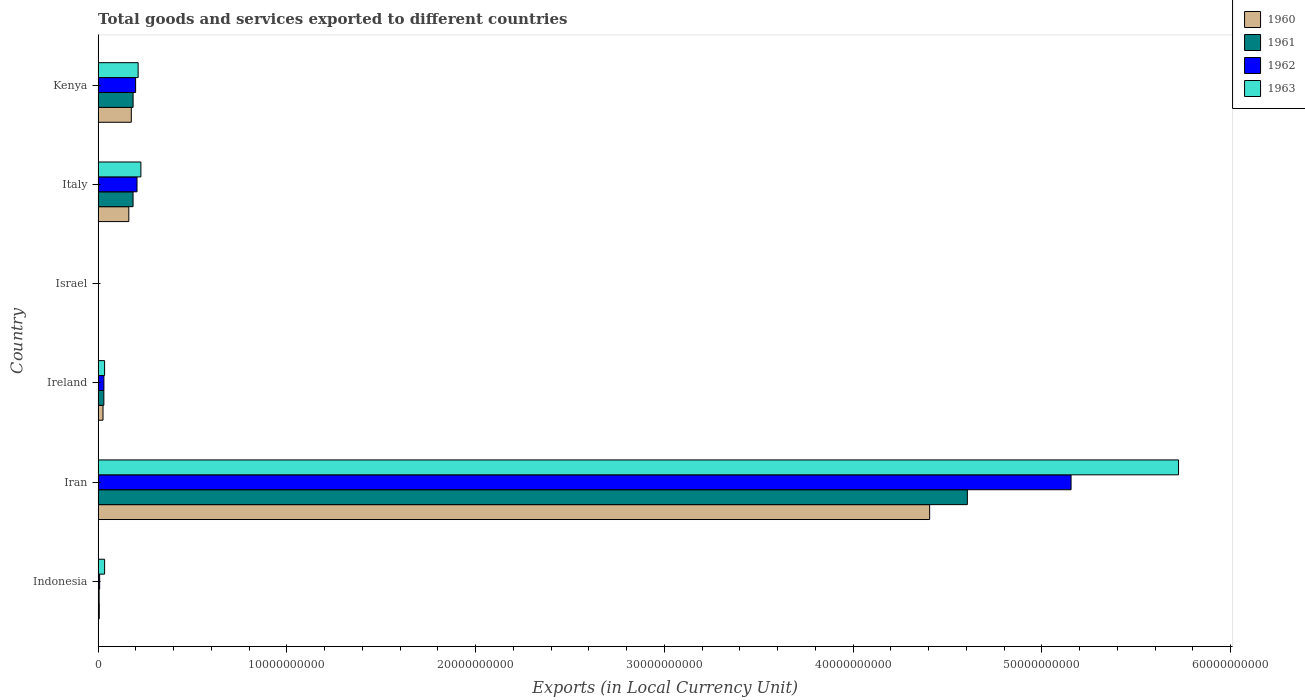How many different coloured bars are there?
Offer a terse response. 4. How many groups of bars are there?
Your answer should be very brief. 6. Are the number of bars on each tick of the Y-axis equal?
Your answer should be compact. Yes. How many bars are there on the 6th tick from the top?
Offer a very short reply. 4. What is the label of the 6th group of bars from the top?
Ensure brevity in your answer.  Indonesia. In how many cases, is the number of bars for a given country not equal to the number of legend labels?
Your answer should be compact. 0. What is the Amount of goods and services exports in 1962 in Kenya?
Provide a succinct answer. 1.99e+09. Across all countries, what is the maximum Amount of goods and services exports in 1962?
Offer a terse response. 5.15e+1. Across all countries, what is the minimum Amount of goods and services exports in 1962?
Keep it short and to the point. 1.34e+05. In which country was the Amount of goods and services exports in 1960 maximum?
Your answer should be compact. Iran. In which country was the Amount of goods and services exports in 1961 minimum?
Your answer should be compact. Israel. What is the total Amount of goods and services exports in 1961 in the graph?
Your answer should be very brief. 5.01e+1. What is the difference between the Amount of goods and services exports in 1960 in Israel and that in Kenya?
Offer a very short reply. -1.76e+09. What is the difference between the Amount of goods and services exports in 1961 in Ireland and the Amount of goods and services exports in 1960 in Indonesia?
Provide a succinct answer. 2.42e+08. What is the average Amount of goods and services exports in 1961 per country?
Provide a succinct answer. 8.35e+09. What is the difference between the Amount of goods and services exports in 1962 and Amount of goods and services exports in 1961 in Ireland?
Your answer should be very brief. 2.58e+06. What is the ratio of the Amount of goods and services exports in 1961 in Indonesia to that in Iran?
Give a very brief answer. 0. What is the difference between the highest and the second highest Amount of goods and services exports in 1960?
Your answer should be compact. 4.23e+1. What is the difference between the highest and the lowest Amount of goods and services exports in 1962?
Your response must be concise. 5.15e+1. In how many countries, is the Amount of goods and services exports in 1961 greater than the average Amount of goods and services exports in 1961 taken over all countries?
Keep it short and to the point. 1. What does the 1st bar from the bottom in Israel represents?
Your response must be concise. 1960. Is it the case that in every country, the sum of the Amount of goods and services exports in 1962 and Amount of goods and services exports in 1963 is greater than the Amount of goods and services exports in 1960?
Ensure brevity in your answer.  Yes. How many bars are there?
Give a very brief answer. 24. Are all the bars in the graph horizontal?
Offer a very short reply. Yes. What is the difference between two consecutive major ticks on the X-axis?
Give a very brief answer. 1.00e+1. Are the values on the major ticks of X-axis written in scientific E-notation?
Ensure brevity in your answer.  No. Does the graph contain grids?
Your answer should be very brief. No. How many legend labels are there?
Offer a very short reply. 4. How are the legend labels stacked?
Keep it short and to the point. Vertical. What is the title of the graph?
Ensure brevity in your answer.  Total goods and services exported to different countries. What is the label or title of the X-axis?
Make the answer very short. Exports (in Local Currency Unit). What is the label or title of the Y-axis?
Offer a very short reply. Country. What is the Exports (in Local Currency Unit) of 1960 in Indonesia?
Provide a short and direct response. 6.20e+07. What is the Exports (in Local Currency Unit) in 1961 in Indonesia?
Offer a very short reply. 5.31e+07. What is the Exports (in Local Currency Unit) in 1962 in Indonesia?
Your response must be concise. 8.19e+07. What is the Exports (in Local Currency Unit) of 1963 in Indonesia?
Offer a very short reply. 3.44e+08. What is the Exports (in Local Currency Unit) of 1960 in Iran?
Make the answer very short. 4.41e+1. What is the Exports (in Local Currency Unit) of 1961 in Iran?
Provide a short and direct response. 4.60e+1. What is the Exports (in Local Currency Unit) in 1962 in Iran?
Ensure brevity in your answer.  5.15e+1. What is the Exports (in Local Currency Unit) in 1963 in Iran?
Make the answer very short. 5.72e+1. What is the Exports (in Local Currency Unit) in 1960 in Ireland?
Provide a succinct answer. 2.60e+08. What is the Exports (in Local Currency Unit) of 1961 in Ireland?
Offer a terse response. 3.04e+08. What is the Exports (in Local Currency Unit) of 1962 in Ireland?
Make the answer very short. 3.07e+08. What is the Exports (in Local Currency Unit) of 1963 in Ireland?
Your answer should be compact. 3.43e+08. What is the Exports (in Local Currency Unit) of 1960 in Israel?
Your response must be concise. 6.19e+04. What is the Exports (in Local Currency Unit) in 1961 in Israel?
Your answer should be very brief. 7.24e+04. What is the Exports (in Local Currency Unit) of 1962 in Israel?
Your answer should be compact. 1.34e+05. What is the Exports (in Local Currency Unit) in 1963 in Israel?
Make the answer very short. 1.67e+05. What is the Exports (in Local Currency Unit) in 1960 in Italy?
Provide a short and direct response. 1.63e+09. What is the Exports (in Local Currency Unit) of 1961 in Italy?
Offer a terse response. 1.85e+09. What is the Exports (in Local Currency Unit) in 1962 in Italy?
Your response must be concise. 2.06e+09. What is the Exports (in Local Currency Unit) in 1963 in Italy?
Offer a very short reply. 2.27e+09. What is the Exports (in Local Currency Unit) in 1960 in Kenya?
Provide a short and direct response. 1.76e+09. What is the Exports (in Local Currency Unit) of 1961 in Kenya?
Provide a short and direct response. 1.85e+09. What is the Exports (in Local Currency Unit) in 1962 in Kenya?
Your answer should be compact. 1.99e+09. What is the Exports (in Local Currency Unit) of 1963 in Kenya?
Offer a terse response. 2.12e+09. Across all countries, what is the maximum Exports (in Local Currency Unit) of 1960?
Offer a terse response. 4.41e+1. Across all countries, what is the maximum Exports (in Local Currency Unit) of 1961?
Offer a terse response. 4.60e+1. Across all countries, what is the maximum Exports (in Local Currency Unit) in 1962?
Your response must be concise. 5.15e+1. Across all countries, what is the maximum Exports (in Local Currency Unit) of 1963?
Provide a short and direct response. 5.72e+1. Across all countries, what is the minimum Exports (in Local Currency Unit) in 1960?
Provide a succinct answer. 6.19e+04. Across all countries, what is the minimum Exports (in Local Currency Unit) of 1961?
Your answer should be compact. 7.24e+04. Across all countries, what is the minimum Exports (in Local Currency Unit) in 1962?
Keep it short and to the point. 1.34e+05. Across all countries, what is the minimum Exports (in Local Currency Unit) of 1963?
Your answer should be very brief. 1.67e+05. What is the total Exports (in Local Currency Unit) of 1960 in the graph?
Ensure brevity in your answer.  4.78e+1. What is the total Exports (in Local Currency Unit) in 1961 in the graph?
Give a very brief answer. 5.01e+1. What is the total Exports (in Local Currency Unit) in 1962 in the graph?
Give a very brief answer. 5.60e+1. What is the total Exports (in Local Currency Unit) of 1963 in the graph?
Give a very brief answer. 6.23e+1. What is the difference between the Exports (in Local Currency Unit) in 1960 in Indonesia and that in Iran?
Provide a short and direct response. -4.40e+1. What is the difference between the Exports (in Local Currency Unit) of 1961 in Indonesia and that in Iran?
Provide a succinct answer. -4.60e+1. What is the difference between the Exports (in Local Currency Unit) in 1962 in Indonesia and that in Iran?
Offer a very short reply. -5.15e+1. What is the difference between the Exports (in Local Currency Unit) of 1963 in Indonesia and that in Iran?
Offer a very short reply. -5.69e+1. What is the difference between the Exports (in Local Currency Unit) in 1960 in Indonesia and that in Ireland?
Ensure brevity in your answer.  -1.98e+08. What is the difference between the Exports (in Local Currency Unit) in 1961 in Indonesia and that in Ireland?
Offer a very short reply. -2.51e+08. What is the difference between the Exports (in Local Currency Unit) in 1962 in Indonesia and that in Ireland?
Your answer should be compact. -2.25e+08. What is the difference between the Exports (in Local Currency Unit) in 1963 in Indonesia and that in Ireland?
Provide a short and direct response. 1.22e+06. What is the difference between the Exports (in Local Currency Unit) in 1960 in Indonesia and that in Israel?
Your response must be concise. 6.19e+07. What is the difference between the Exports (in Local Currency Unit) in 1961 in Indonesia and that in Israel?
Provide a short and direct response. 5.31e+07. What is the difference between the Exports (in Local Currency Unit) in 1962 in Indonesia and that in Israel?
Provide a succinct answer. 8.18e+07. What is the difference between the Exports (in Local Currency Unit) in 1963 in Indonesia and that in Israel?
Your answer should be very brief. 3.44e+08. What is the difference between the Exports (in Local Currency Unit) in 1960 in Indonesia and that in Italy?
Your response must be concise. -1.56e+09. What is the difference between the Exports (in Local Currency Unit) of 1961 in Indonesia and that in Italy?
Provide a short and direct response. -1.80e+09. What is the difference between the Exports (in Local Currency Unit) in 1962 in Indonesia and that in Italy?
Your answer should be very brief. -1.98e+09. What is the difference between the Exports (in Local Currency Unit) of 1963 in Indonesia and that in Italy?
Give a very brief answer. -1.92e+09. What is the difference between the Exports (in Local Currency Unit) of 1960 in Indonesia and that in Kenya?
Your response must be concise. -1.70e+09. What is the difference between the Exports (in Local Currency Unit) in 1961 in Indonesia and that in Kenya?
Offer a very short reply. -1.80e+09. What is the difference between the Exports (in Local Currency Unit) in 1962 in Indonesia and that in Kenya?
Give a very brief answer. -1.90e+09. What is the difference between the Exports (in Local Currency Unit) in 1963 in Indonesia and that in Kenya?
Keep it short and to the point. -1.78e+09. What is the difference between the Exports (in Local Currency Unit) in 1960 in Iran and that in Ireland?
Give a very brief answer. 4.38e+1. What is the difference between the Exports (in Local Currency Unit) in 1961 in Iran and that in Ireland?
Make the answer very short. 4.57e+1. What is the difference between the Exports (in Local Currency Unit) of 1962 in Iran and that in Ireland?
Make the answer very short. 5.12e+1. What is the difference between the Exports (in Local Currency Unit) in 1963 in Iran and that in Ireland?
Your response must be concise. 5.69e+1. What is the difference between the Exports (in Local Currency Unit) of 1960 in Iran and that in Israel?
Offer a very short reply. 4.41e+1. What is the difference between the Exports (in Local Currency Unit) of 1961 in Iran and that in Israel?
Keep it short and to the point. 4.60e+1. What is the difference between the Exports (in Local Currency Unit) of 1962 in Iran and that in Israel?
Your answer should be very brief. 5.15e+1. What is the difference between the Exports (in Local Currency Unit) in 1963 in Iran and that in Israel?
Make the answer very short. 5.72e+1. What is the difference between the Exports (in Local Currency Unit) of 1960 in Iran and that in Italy?
Keep it short and to the point. 4.24e+1. What is the difference between the Exports (in Local Currency Unit) of 1961 in Iran and that in Italy?
Offer a very short reply. 4.42e+1. What is the difference between the Exports (in Local Currency Unit) of 1962 in Iran and that in Italy?
Your answer should be compact. 4.95e+1. What is the difference between the Exports (in Local Currency Unit) in 1963 in Iran and that in Italy?
Make the answer very short. 5.50e+1. What is the difference between the Exports (in Local Currency Unit) of 1960 in Iran and that in Kenya?
Your answer should be very brief. 4.23e+1. What is the difference between the Exports (in Local Currency Unit) in 1961 in Iran and that in Kenya?
Give a very brief answer. 4.42e+1. What is the difference between the Exports (in Local Currency Unit) in 1962 in Iran and that in Kenya?
Ensure brevity in your answer.  4.96e+1. What is the difference between the Exports (in Local Currency Unit) of 1963 in Iran and that in Kenya?
Offer a terse response. 5.51e+1. What is the difference between the Exports (in Local Currency Unit) of 1960 in Ireland and that in Israel?
Provide a short and direct response. 2.60e+08. What is the difference between the Exports (in Local Currency Unit) in 1961 in Ireland and that in Israel?
Offer a very short reply. 3.04e+08. What is the difference between the Exports (in Local Currency Unit) of 1962 in Ireland and that in Israel?
Give a very brief answer. 3.06e+08. What is the difference between the Exports (in Local Currency Unit) of 1963 in Ireland and that in Israel?
Your response must be concise. 3.43e+08. What is the difference between the Exports (in Local Currency Unit) in 1960 in Ireland and that in Italy?
Offer a terse response. -1.37e+09. What is the difference between the Exports (in Local Currency Unit) in 1961 in Ireland and that in Italy?
Your answer should be compact. -1.55e+09. What is the difference between the Exports (in Local Currency Unit) in 1962 in Ireland and that in Italy?
Give a very brief answer. -1.75e+09. What is the difference between the Exports (in Local Currency Unit) in 1963 in Ireland and that in Italy?
Make the answer very short. -1.92e+09. What is the difference between the Exports (in Local Currency Unit) of 1960 in Ireland and that in Kenya?
Offer a terse response. -1.50e+09. What is the difference between the Exports (in Local Currency Unit) in 1961 in Ireland and that in Kenya?
Your response must be concise. -1.55e+09. What is the difference between the Exports (in Local Currency Unit) of 1962 in Ireland and that in Kenya?
Keep it short and to the point. -1.68e+09. What is the difference between the Exports (in Local Currency Unit) of 1963 in Ireland and that in Kenya?
Offer a very short reply. -1.78e+09. What is the difference between the Exports (in Local Currency Unit) in 1960 in Israel and that in Italy?
Keep it short and to the point. -1.63e+09. What is the difference between the Exports (in Local Currency Unit) in 1961 in Israel and that in Italy?
Provide a short and direct response. -1.85e+09. What is the difference between the Exports (in Local Currency Unit) of 1962 in Israel and that in Italy?
Provide a succinct answer. -2.06e+09. What is the difference between the Exports (in Local Currency Unit) in 1963 in Israel and that in Italy?
Make the answer very short. -2.27e+09. What is the difference between the Exports (in Local Currency Unit) of 1960 in Israel and that in Kenya?
Offer a very short reply. -1.76e+09. What is the difference between the Exports (in Local Currency Unit) of 1961 in Israel and that in Kenya?
Provide a short and direct response. -1.85e+09. What is the difference between the Exports (in Local Currency Unit) in 1962 in Israel and that in Kenya?
Your answer should be compact. -1.99e+09. What is the difference between the Exports (in Local Currency Unit) of 1963 in Israel and that in Kenya?
Provide a short and direct response. -2.12e+09. What is the difference between the Exports (in Local Currency Unit) of 1960 in Italy and that in Kenya?
Ensure brevity in your answer.  -1.31e+08. What is the difference between the Exports (in Local Currency Unit) in 1961 in Italy and that in Kenya?
Keep it short and to the point. -1.45e+06. What is the difference between the Exports (in Local Currency Unit) in 1962 in Italy and that in Kenya?
Provide a succinct answer. 7.40e+07. What is the difference between the Exports (in Local Currency Unit) in 1963 in Italy and that in Kenya?
Your answer should be compact. 1.46e+08. What is the difference between the Exports (in Local Currency Unit) of 1960 in Indonesia and the Exports (in Local Currency Unit) of 1961 in Iran?
Your answer should be compact. -4.60e+1. What is the difference between the Exports (in Local Currency Unit) of 1960 in Indonesia and the Exports (in Local Currency Unit) of 1962 in Iran?
Ensure brevity in your answer.  -5.15e+1. What is the difference between the Exports (in Local Currency Unit) in 1960 in Indonesia and the Exports (in Local Currency Unit) in 1963 in Iran?
Make the answer very short. -5.72e+1. What is the difference between the Exports (in Local Currency Unit) of 1961 in Indonesia and the Exports (in Local Currency Unit) of 1962 in Iran?
Ensure brevity in your answer.  -5.15e+1. What is the difference between the Exports (in Local Currency Unit) in 1961 in Indonesia and the Exports (in Local Currency Unit) in 1963 in Iran?
Keep it short and to the point. -5.72e+1. What is the difference between the Exports (in Local Currency Unit) of 1962 in Indonesia and the Exports (in Local Currency Unit) of 1963 in Iran?
Keep it short and to the point. -5.72e+1. What is the difference between the Exports (in Local Currency Unit) in 1960 in Indonesia and the Exports (in Local Currency Unit) in 1961 in Ireland?
Your answer should be compact. -2.42e+08. What is the difference between the Exports (in Local Currency Unit) in 1960 in Indonesia and the Exports (in Local Currency Unit) in 1962 in Ireland?
Give a very brief answer. -2.45e+08. What is the difference between the Exports (in Local Currency Unit) of 1960 in Indonesia and the Exports (in Local Currency Unit) of 1963 in Ireland?
Your answer should be compact. -2.81e+08. What is the difference between the Exports (in Local Currency Unit) of 1961 in Indonesia and the Exports (in Local Currency Unit) of 1962 in Ireland?
Provide a short and direct response. -2.53e+08. What is the difference between the Exports (in Local Currency Unit) in 1961 in Indonesia and the Exports (in Local Currency Unit) in 1963 in Ireland?
Offer a terse response. -2.90e+08. What is the difference between the Exports (in Local Currency Unit) in 1962 in Indonesia and the Exports (in Local Currency Unit) in 1963 in Ireland?
Keep it short and to the point. -2.61e+08. What is the difference between the Exports (in Local Currency Unit) of 1960 in Indonesia and the Exports (in Local Currency Unit) of 1961 in Israel?
Your answer should be compact. 6.19e+07. What is the difference between the Exports (in Local Currency Unit) of 1960 in Indonesia and the Exports (in Local Currency Unit) of 1962 in Israel?
Your response must be concise. 6.18e+07. What is the difference between the Exports (in Local Currency Unit) of 1960 in Indonesia and the Exports (in Local Currency Unit) of 1963 in Israel?
Ensure brevity in your answer.  6.18e+07. What is the difference between the Exports (in Local Currency Unit) of 1961 in Indonesia and the Exports (in Local Currency Unit) of 1962 in Israel?
Keep it short and to the point. 5.30e+07. What is the difference between the Exports (in Local Currency Unit) in 1961 in Indonesia and the Exports (in Local Currency Unit) in 1963 in Israel?
Give a very brief answer. 5.30e+07. What is the difference between the Exports (in Local Currency Unit) in 1962 in Indonesia and the Exports (in Local Currency Unit) in 1963 in Israel?
Make the answer very short. 8.17e+07. What is the difference between the Exports (in Local Currency Unit) of 1960 in Indonesia and the Exports (in Local Currency Unit) of 1961 in Italy?
Your response must be concise. -1.79e+09. What is the difference between the Exports (in Local Currency Unit) of 1960 in Indonesia and the Exports (in Local Currency Unit) of 1962 in Italy?
Your answer should be very brief. -2.00e+09. What is the difference between the Exports (in Local Currency Unit) in 1960 in Indonesia and the Exports (in Local Currency Unit) in 1963 in Italy?
Your answer should be very brief. -2.20e+09. What is the difference between the Exports (in Local Currency Unit) of 1961 in Indonesia and the Exports (in Local Currency Unit) of 1962 in Italy?
Provide a succinct answer. -2.01e+09. What is the difference between the Exports (in Local Currency Unit) of 1961 in Indonesia and the Exports (in Local Currency Unit) of 1963 in Italy?
Your answer should be compact. -2.21e+09. What is the difference between the Exports (in Local Currency Unit) of 1962 in Indonesia and the Exports (in Local Currency Unit) of 1963 in Italy?
Keep it short and to the point. -2.18e+09. What is the difference between the Exports (in Local Currency Unit) in 1960 in Indonesia and the Exports (in Local Currency Unit) in 1961 in Kenya?
Provide a succinct answer. -1.79e+09. What is the difference between the Exports (in Local Currency Unit) in 1960 in Indonesia and the Exports (in Local Currency Unit) in 1962 in Kenya?
Your response must be concise. -1.92e+09. What is the difference between the Exports (in Local Currency Unit) of 1960 in Indonesia and the Exports (in Local Currency Unit) of 1963 in Kenya?
Your response must be concise. -2.06e+09. What is the difference between the Exports (in Local Currency Unit) in 1961 in Indonesia and the Exports (in Local Currency Unit) in 1962 in Kenya?
Your answer should be very brief. -1.93e+09. What is the difference between the Exports (in Local Currency Unit) in 1961 in Indonesia and the Exports (in Local Currency Unit) in 1963 in Kenya?
Provide a succinct answer. -2.07e+09. What is the difference between the Exports (in Local Currency Unit) in 1962 in Indonesia and the Exports (in Local Currency Unit) in 1963 in Kenya?
Provide a short and direct response. -2.04e+09. What is the difference between the Exports (in Local Currency Unit) of 1960 in Iran and the Exports (in Local Currency Unit) of 1961 in Ireland?
Offer a terse response. 4.37e+1. What is the difference between the Exports (in Local Currency Unit) of 1960 in Iran and the Exports (in Local Currency Unit) of 1962 in Ireland?
Provide a short and direct response. 4.37e+1. What is the difference between the Exports (in Local Currency Unit) in 1960 in Iran and the Exports (in Local Currency Unit) in 1963 in Ireland?
Offer a very short reply. 4.37e+1. What is the difference between the Exports (in Local Currency Unit) of 1961 in Iran and the Exports (in Local Currency Unit) of 1962 in Ireland?
Ensure brevity in your answer.  4.57e+1. What is the difference between the Exports (in Local Currency Unit) of 1961 in Iran and the Exports (in Local Currency Unit) of 1963 in Ireland?
Offer a very short reply. 4.57e+1. What is the difference between the Exports (in Local Currency Unit) in 1962 in Iran and the Exports (in Local Currency Unit) in 1963 in Ireland?
Ensure brevity in your answer.  5.12e+1. What is the difference between the Exports (in Local Currency Unit) of 1960 in Iran and the Exports (in Local Currency Unit) of 1961 in Israel?
Ensure brevity in your answer.  4.41e+1. What is the difference between the Exports (in Local Currency Unit) in 1960 in Iran and the Exports (in Local Currency Unit) in 1962 in Israel?
Your answer should be very brief. 4.41e+1. What is the difference between the Exports (in Local Currency Unit) of 1960 in Iran and the Exports (in Local Currency Unit) of 1963 in Israel?
Offer a very short reply. 4.41e+1. What is the difference between the Exports (in Local Currency Unit) of 1961 in Iran and the Exports (in Local Currency Unit) of 1962 in Israel?
Provide a short and direct response. 4.60e+1. What is the difference between the Exports (in Local Currency Unit) of 1961 in Iran and the Exports (in Local Currency Unit) of 1963 in Israel?
Your answer should be very brief. 4.60e+1. What is the difference between the Exports (in Local Currency Unit) in 1962 in Iran and the Exports (in Local Currency Unit) in 1963 in Israel?
Provide a short and direct response. 5.15e+1. What is the difference between the Exports (in Local Currency Unit) of 1960 in Iran and the Exports (in Local Currency Unit) of 1961 in Italy?
Give a very brief answer. 4.22e+1. What is the difference between the Exports (in Local Currency Unit) in 1960 in Iran and the Exports (in Local Currency Unit) in 1962 in Italy?
Keep it short and to the point. 4.20e+1. What is the difference between the Exports (in Local Currency Unit) in 1960 in Iran and the Exports (in Local Currency Unit) in 1963 in Italy?
Offer a terse response. 4.18e+1. What is the difference between the Exports (in Local Currency Unit) in 1961 in Iran and the Exports (in Local Currency Unit) in 1962 in Italy?
Your response must be concise. 4.40e+1. What is the difference between the Exports (in Local Currency Unit) of 1961 in Iran and the Exports (in Local Currency Unit) of 1963 in Italy?
Provide a short and direct response. 4.38e+1. What is the difference between the Exports (in Local Currency Unit) in 1962 in Iran and the Exports (in Local Currency Unit) in 1963 in Italy?
Your answer should be very brief. 4.93e+1. What is the difference between the Exports (in Local Currency Unit) of 1960 in Iran and the Exports (in Local Currency Unit) of 1961 in Kenya?
Give a very brief answer. 4.22e+1. What is the difference between the Exports (in Local Currency Unit) of 1960 in Iran and the Exports (in Local Currency Unit) of 1962 in Kenya?
Offer a terse response. 4.21e+1. What is the difference between the Exports (in Local Currency Unit) of 1960 in Iran and the Exports (in Local Currency Unit) of 1963 in Kenya?
Ensure brevity in your answer.  4.19e+1. What is the difference between the Exports (in Local Currency Unit) in 1961 in Iran and the Exports (in Local Currency Unit) in 1962 in Kenya?
Keep it short and to the point. 4.41e+1. What is the difference between the Exports (in Local Currency Unit) of 1961 in Iran and the Exports (in Local Currency Unit) of 1963 in Kenya?
Provide a short and direct response. 4.39e+1. What is the difference between the Exports (in Local Currency Unit) of 1962 in Iran and the Exports (in Local Currency Unit) of 1963 in Kenya?
Your answer should be very brief. 4.94e+1. What is the difference between the Exports (in Local Currency Unit) in 1960 in Ireland and the Exports (in Local Currency Unit) in 1961 in Israel?
Your answer should be very brief. 2.60e+08. What is the difference between the Exports (in Local Currency Unit) in 1960 in Ireland and the Exports (in Local Currency Unit) in 1962 in Israel?
Your answer should be very brief. 2.60e+08. What is the difference between the Exports (in Local Currency Unit) in 1960 in Ireland and the Exports (in Local Currency Unit) in 1963 in Israel?
Your response must be concise. 2.60e+08. What is the difference between the Exports (in Local Currency Unit) of 1961 in Ireland and the Exports (in Local Currency Unit) of 1962 in Israel?
Your response must be concise. 3.04e+08. What is the difference between the Exports (in Local Currency Unit) in 1961 in Ireland and the Exports (in Local Currency Unit) in 1963 in Israel?
Your answer should be very brief. 3.04e+08. What is the difference between the Exports (in Local Currency Unit) in 1962 in Ireland and the Exports (in Local Currency Unit) in 1963 in Israel?
Your answer should be very brief. 3.06e+08. What is the difference between the Exports (in Local Currency Unit) in 1960 in Ireland and the Exports (in Local Currency Unit) in 1961 in Italy?
Provide a succinct answer. -1.59e+09. What is the difference between the Exports (in Local Currency Unit) of 1960 in Ireland and the Exports (in Local Currency Unit) of 1962 in Italy?
Your response must be concise. -1.80e+09. What is the difference between the Exports (in Local Currency Unit) of 1960 in Ireland and the Exports (in Local Currency Unit) of 1963 in Italy?
Make the answer very short. -2.01e+09. What is the difference between the Exports (in Local Currency Unit) of 1961 in Ireland and the Exports (in Local Currency Unit) of 1962 in Italy?
Your response must be concise. -1.76e+09. What is the difference between the Exports (in Local Currency Unit) in 1961 in Ireland and the Exports (in Local Currency Unit) in 1963 in Italy?
Provide a short and direct response. -1.96e+09. What is the difference between the Exports (in Local Currency Unit) of 1962 in Ireland and the Exports (in Local Currency Unit) of 1963 in Italy?
Offer a terse response. -1.96e+09. What is the difference between the Exports (in Local Currency Unit) of 1960 in Ireland and the Exports (in Local Currency Unit) of 1961 in Kenya?
Provide a succinct answer. -1.59e+09. What is the difference between the Exports (in Local Currency Unit) of 1960 in Ireland and the Exports (in Local Currency Unit) of 1962 in Kenya?
Ensure brevity in your answer.  -1.73e+09. What is the difference between the Exports (in Local Currency Unit) in 1960 in Ireland and the Exports (in Local Currency Unit) in 1963 in Kenya?
Your response must be concise. -1.86e+09. What is the difference between the Exports (in Local Currency Unit) of 1961 in Ireland and the Exports (in Local Currency Unit) of 1962 in Kenya?
Keep it short and to the point. -1.68e+09. What is the difference between the Exports (in Local Currency Unit) in 1961 in Ireland and the Exports (in Local Currency Unit) in 1963 in Kenya?
Your response must be concise. -1.82e+09. What is the difference between the Exports (in Local Currency Unit) in 1962 in Ireland and the Exports (in Local Currency Unit) in 1963 in Kenya?
Provide a short and direct response. -1.81e+09. What is the difference between the Exports (in Local Currency Unit) of 1960 in Israel and the Exports (in Local Currency Unit) of 1961 in Italy?
Provide a short and direct response. -1.85e+09. What is the difference between the Exports (in Local Currency Unit) in 1960 in Israel and the Exports (in Local Currency Unit) in 1962 in Italy?
Offer a very short reply. -2.06e+09. What is the difference between the Exports (in Local Currency Unit) in 1960 in Israel and the Exports (in Local Currency Unit) in 1963 in Italy?
Provide a short and direct response. -2.27e+09. What is the difference between the Exports (in Local Currency Unit) of 1961 in Israel and the Exports (in Local Currency Unit) of 1962 in Italy?
Your answer should be compact. -2.06e+09. What is the difference between the Exports (in Local Currency Unit) of 1961 in Israel and the Exports (in Local Currency Unit) of 1963 in Italy?
Your response must be concise. -2.27e+09. What is the difference between the Exports (in Local Currency Unit) of 1962 in Israel and the Exports (in Local Currency Unit) of 1963 in Italy?
Offer a very short reply. -2.27e+09. What is the difference between the Exports (in Local Currency Unit) of 1960 in Israel and the Exports (in Local Currency Unit) of 1961 in Kenya?
Give a very brief answer. -1.85e+09. What is the difference between the Exports (in Local Currency Unit) of 1960 in Israel and the Exports (in Local Currency Unit) of 1962 in Kenya?
Provide a succinct answer. -1.99e+09. What is the difference between the Exports (in Local Currency Unit) in 1960 in Israel and the Exports (in Local Currency Unit) in 1963 in Kenya?
Offer a terse response. -2.12e+09. What is the difference between the Exports (in Local Currency Unit) of 1961 in Israel and the Exports (in Local Currency Unit) of 1962 in Kenya?
Offer a very short reply. -1.99e+09. What is the difference between the Exports (in Local Currency Unit) of 1961 in Israel and the Exports (in Local Currency Unit) of 1963 in Kenya?
Make the answer very short. -2.12e+09. What is the difference between the Exports (in Local Currency Unit) of 1962 in Israel and the Exports (in Local Currency Unit) of 1963 in Kenya?
Your answer should be compact. -2.12e+09. What is the difference between the Exports (in Local Currency Unit) in 1960 in Italy and the Exports (in Local Currency Unit) in 1961 in Kenya?
Give a very brief answer. -2.27e+08. What is the difference between the Exports (in Local Currency Unit) in 1960 in Italy and the Exports (in Local Currency Unit) in 1962 in Kenya?
Your answer should be compact. -3.60e+08. What is the difference between the Exports (in Local Currency Unit) in 1960 in Italy and the Exports (in Local Currency Unit) in 1963 in Kenya?
Provide a succinct answer. -4.94e+08. What is the difference between the Exports (in Local Currency Unit) in 1961 in Italy and the Exports (in Local Currency Unit) in 1962 in Kenya?
Provide a short and direct response. -1.35e+08. What is the difference between the Exports (in Local Currency Unit) of 1961 in Italy and the Exports (in Local Currency Unit) of 1963 in Kenya?
Provide a succinct answer. -2.68e+08. What is the difference between the Exports (in Local Currency Unit) in 1962 in Italy and the Exports (in Local Currency Unit) in 1963 in Kenya?
Offer a terse response. -5.95e+07. What is the average Exports (in Local Currency Unit) in 1960 per country?
Provide a succinct answer. 7.96e+09. What is the average Exports (in Local Currency Unit) of 1961 per country?
Ensure brevity in your answer.  8.35e+09. What is the average Exports (in Local Currency Unit) of 1962 per country?
Keep it short and to the point. 9.33e+09. What is the average Exports (in Local Currency Unit) in 1963 per country?
Offer a very short reply. 1.04e+1. What is the difference between the Exports (in Local Currency Unit) in 1960 and Exports (in Local Currency Unit) in 1961 in Indonesia?
Ensure brevity in your answer.  8.85e+06. What is the difference between the Exports (in Local Currency Unit) of 1960 and Exports (in Local Currency Unit) of 1962 in Indonesia?
Make the answer very short. -1.99e+07. What is the difference between the Exports (in Local Currency Unit) of 1960 and Exports (in Local Currency Unit) of 1963 in Indonesia?
Your answer should be compact. -2.82e+08. What is the difference between the Exports (in Local Currency Unit) of 1961 and Exports (in Local Currency Unit) of 1962 in Indonesia?
Ensure brevity in your answer.  -2.88e+07. What is the difference between the Exports (in Local Currency Unit) in 1961 and Exports (in Local Currency Unit) in 1963 in Indonesia?
Make the answer very short. -2.91e+08. What is the difference between the Exports (in Local Currency Unit) in 1962 and Exports (in Local Currency Unit) in 1963 in Indonesia?
Your response must be concise. -2.62e+08. What is the difference between the Exports (in Local Currency Unit) in 1960 and Exports (in Local Currency Unit) in 1961 in Iran?
Offer a terse response. -2.00e+09. What is the difference between the Exports (in Local Currency Unit) in 1960 and Exports (in Local Currency Unit) in 1962 in Iran?
Ensure brevity in your answer.  -7.49e+09. What is the difference between the Exports (in Local Currency Unit) in 1960 and Exports (in Local Currency Unit) in 1963 in Iran?
Offer a terse response. -1.32e+1. What is the difference between the Exports (in Local Currency Unit) in 1961 and Exports (in Local Currency Unit) in 1962 in Iran?
Offer a very short reply. -5.49e+09. What is the difference between the Exports (in Local Currency Unit) of 1961 and Exports (in Local Currency Unit) of 1963 in Iran?
Make the answer very short. -1.12e+1. What is the difference between the Exports (in Local Currency Unit) of 1962 and Exports (in Local Currency Unit) of 1963 in Iran?
Your response must be concise. -5.69e+09. What is the difference between the Exports (in Local Currency Unit) of 1960 and Exports (in Local Currency Unit) of 1961 in Ireland?
Your answer should be compact. -4.43e+07. What is the difference between the Exports (in Local Currency Unit) of 1960 and Exports (in Local Currency Unit) of 1962 in Ireland?
Make the answer very short. -4.69e+07. What is the difference between the Exports (in Local Currency Unit) in 1960 and Exports (in Local Currency Unit) in 1963 in Ireland?
Give a very brief answer. -8.33e+07. What is the difference between the Exports (in Local Currency Unit) in 1961 and Exports (in Local Currency Unit) in 1962 in Ireland?
Give a very brief answer. -2.58e+06. What is the difference between the Exports (in Local Currency Unit) of 1961 and Exports (in Local Currency Unit) of 1963 in Ireland?
Ensure brevity in your answer.  -3.90e+07. What is the difference between the Exports (in Local Currency Unit) in 1962 and Exports (in Local Currency Unit) in 1963 in Ireland?
Your answer should be very brief. -3.64e+07. What is the difference between the Exports (in Local Currency Unit) in 1960 and Exports (in Local Currency Unit) in 1961 in Israel?
Provide a short and direct response. -1.05e+04. What is the difference between the Exports (in Local Currency Unit) of 1960 and Exports (in Local Currency Unit) of 1962 in Israel?
Offer a terse response. -7.21e+04. What is the difference between the Exports (in Local Currency Unit) of 1960 and Exports (in Local Currency Unit) of 1963 in Israel?
Your answer should be very brief. -1.06e+05. What is the difference between the Exports (in Local Currency Unit) in 1961 and Exports (in Local Currency Unit) in 1962 in Israel?
Keep it short and to the point. -6.16e+04. What is the difference between the Exports (in Local Currency Unit) of 1961 and Exports (in Local Currency Unit) of 1963 in Israel?
Your answer should be compact. -9.50e+04. What is the difference between the Exports (in Local Currency Unit) in 1962 and Exports (in Local Currency Unit) in 1963 in Israel?
Provide a succinct answer. -3.34e+04. What is the difference between the Exports (in Local Currency Unit) in 1960 and Exports (in Local Currency Unit) in 1961 in Italy?
Your response must be concise. -2.25e+08. What is the difference between the Exports (in Local Currency Unit) in 1960 and Exports (in Local Currency Unit) in 1962 in Italy?
Make the answer very short. -4.34e+08. What is the difference between the Exports (in Local Currency Unit) of 1960 and Exports (in Local Currency Unit) of 1963 in Italy?
Give a very brief answer. -6.40e+08. What is the difference between the Exports (in Local Currency Unit) in 1961 and Exports (in Local Currency Unit) in 1962 in Italy?
Provide a succinct answer. -2.09e+08. What is the difference between the Exports (in Local Currency Unit) of 1961 and Exports (in Local Currency Unit) of 1963 in Italy?
Your answer should be very brief. -4.14e+08. What is the difference between the Exports (in Local Currency Unit) of 1962 and Exports (in Local Currency Unit) of 1963 in Italy?
Ensure brevity in your answer.  -2.05e+08. What is the difference between the Exports (in Local Currency Unit) in 1960 and Exports (in Local Currency Unit) in 1961 in Kenya?
Offer a very short reply. -9.56e+07. What is the difference between the Exports (in Local Currency Unit) in 1960 and Exports (in Local Currency Unit) in 1962 in Kenya?
Your answer should be very brief. -2.29e+08. What is the difference between the Exports (in Local Currency Unit) in 1960 and Exports (in Local Currency Unit) in 1963 in Kenya?
Make the answer very short. -3.63e+08. What is the difference between the Exports (in Local Currency Unit) of 1961 and Exports (in Local Currency Unit) of 1962 in Kenya?
Your answer should be very brief. -1.33e+08. What is the difference between the Exports (in Local Currency Unit) in 1961 and Exports (in Local Currency Unit) in 1963 in Kenya?
Offer a very short reply. -2.67e+08. What is the difference between the Exports (in Local Currency Unit) in 1962 and Exports (in Local Currency Unit) in 1963 in Kenya?
Offer a terse response. -1.34e+08. What is the ratio of the Exports (in Local Currency Unit) of 1960 in Indonesia to that in Iran?
Offer a terse response. 0. What is the ratio of the Exports (in Local Currency Unit) in 1961 in Indonesia to that in Iran?
Offer a very short reply. 0. What is the ratio of the Exports (in Local Currency Unit) of 1962 in Indonesia to that in Iran?
Keep it short and to the point. 0. What is the ratio of the Exports (in Local Currency Unit) in 1963 in Indonesia to that in Iran?
Keep it short and to the point. 0.01. What is the ratio of the Exports (in Local Currency Unit) in 1960 in Indonesia to that in Ireland?
Your response must be concise. 0.24. What is the ratio of the Exports (in Local Currency Unit) in 1961 in Indonesia to that in Ireland?
Your answer should be compact. 0.17. What is the ratio of the Exports (in Local Currency Unit) in 1962 in Indonesia to that in Ireland?
Offer a terse response. 0.27. What is the ratio of the Exports (in Local Currency Unit) in 1963 in Indonesia to that in Ireland?
Your answer should be very brief. 1. What is the ratio of the Exports (in Local Currency Unit) in 1960 in Indonesia to that in Israel?
Provide a short and direct response. 1001.31. What is the ratio of the Exports (in Local Currency Unit) of 1961 in Indonesia to that in Israel?
Your answer should be very brief. 733.8. What is the ratio of the Exports (in Local Currency Unit) of 1962 in Indonesia to that in Israel?
Offer a terse response. 611.22. What is the ratio of the Exports (in Local Currency Unit) in 1963 in Indonesia to that in Israel?
Provide a short and direct response. 2056.26. What is the ratio of the Exports (in Local Currency Unit) in 1960 in Indonesia to that in Italy?
Your answer should be very brief. 0.04. What is the ratio of the Exports (in Local Currency Unit) of 1961 in Indonesia to that in Italy?
Make the answer very short. 0.03. What is the ratio of the Exports (in Local Currency Unit) of 1962 in Indonesia to that in Italy?
Ensure brevity in your answer.  0.04. What is the ratio of the Exports (in Local Currency Unit) in 1963 in Indonesia to that in Italy?
Ensure brevity in your answer.  0.15. What is the ratio of the Exports (in Local Currency Unit) in 1960 in Indonesia to that in Kenya?
Your answer should be compact. 0.04. What is the ratio of the Exports (in Local Currency Unit) of 1961 in Indonesia to that in Kenya?
Provide a short and direct response. 0.03. What is the ratio of the Exports (in Local Currency Unit) of 1962 in Indonesia to that in Kenya?
Give a very brief answer. 0.04. What is the ratio of the Exports (in Local Currency Unit) of 1963 in Indonesia to that in Kenya?
Offer a terse response. 0.16. What is the ratio of the Exports (in Local Currency Unit) of 1960 in Iran to that in Ireland?
Provide a succinct answer. 169.64. What is the ratio of the Exports (in Local Currency Unit) of 1961 in Iran to that in Ireland?
Offer a terse response. 151.49. What is the ratio of the Exports (in Local Currency Unit) of 1962 in Iran to that in Ireland?
Your response must be concise. 168.13. What is the ratio of the Exports (in Local Currency Unit) of 1963 in Iran to that in Ireland?
Make the answer very short. 166.87. What is the ratio of the Exports (in Local Currency Unit) of 1960 in Iran to that in Israel?
Keep it short and to the point. 7.12e+05. What is the ratio of the Exports (in Local Currency Unit) of 1961 in Iran to that in Israel?
Ensure brevity in your answer.  6.36e+05. What is the ratio of the Exports (in Local Currency Unit) of 1962 in Iran to that in Israel?
Your answer should be very brief. 3.85e+05. What is the ratio of the Exports (in Local Currency Unit) of 1963 in Iran to that in Israel?
Your response must be concise. 3.42e+05. What is the ratio of the Exports (in Local Currency Unit) of 1960 in Iran to that in Italy?
Your response must be concise. 27.08. What is the ratio of the Exports (in Local Currency Unit) of 1961 in Iran to that in Italy?
Give a very brief answer. 24.87. What is the ratio of the Exports (in Local Currency Unit) of 1962 in Iran to that in Italy?
Keep it short and to the point. 25.01. What is the ratio of the Exports (in Local Currency Unit) of 1963 in Iran to that in Italy?
Make the answer very short. 25.26. What is the ratio of the Exports (in Local Currency Unit) in 1960 in Iran to that in Kenya?
Your answer should be compact. 25.07. What is the ratio of the Exports (in Local Currency Unit) in 1961 in Iran to that in Kenya?
Offer a terse response. 24.85. What is the ratio of the Exports (in Local Currency Unit) in 1962 in Iran to that in Kenya?
Provide a short and direct response. 25.95. What is the ratio of the Exports (in Local Currency Unit) in 1963 in Iran to that in Kenya?
Your response must be concise. 27. What is the ratio of the Exports (in Local Currency Unit) in 1960 in Ireland to that in Israel?
Offer a terse response. 4195.01. What is the ratio of the Exports (in Local Currency Unit) in 1961 in Ireland to that in Israel?
Offer a terse response. 4198.66. What is the ratio of the Exports (in Local Currency Unit) of 1962 in Ireland to that in Israel?
Provide a succinct answer. 2287.81. What is the ratio of the Exports (in Local Currency Unit) in 1963 in Ireland to that in Israel?
Give a very brief answer. 2048.97. What is the ratio of the Exports (in Local Currency Unit) of 1960 in Ireland to that in Italy?
Your response must be concise. 0.16. What is the ratio of the Exports (in Local Currency Unit) in 1961 in Ireland to that in Italy?
Provide a succinct answer. 0.16. What is the ratio of the Exports (in Local Currency Unit) in 1962 in Ireland to that in Italy?
Offer a terse response. 0.15. What is the ratio of the Exports (in Local Currency Unit) in 1963 in Ireland to that in Italy?
Your response must be concise. 0.15. What is the ratio of the Exports (in Local Currency Unit) in 1960 in Ireland to that in Kenya?
Your answer should be very brief. 0.15. What is the ratio of the Exports (in Local Currency Unit) in 1961 in Ireland to that in Kenya?
Offer a very short reply. 0.16. What is the ratio of the Exports (in Local Currency Unit) of 1962 in Ireland to that in Kenya?
Your answer should be compact. 0.15. What is the ratio of the Exports (in Local Currency Unit) of 1963 in Ireland to that in Kenya?
Make the answer very short. 0.16. What is the ratio of the Exports (in Local Currency Unit) in 1960 in Israel to that in Italy?
Keep it short and to the point. 0. What is the ratio of the Exports (in Local Currency Unit) of 1961 in Israel to that in Kenya?
Provide a succinct answer. 0. What is the ratio of the Exports (in Local Currency Unit) of 1960 in Italy to that in Kenya?
Your response must be concise. 0.93. What is the ratio of the Exports (in Local Currency Unit) in 1962 in Italy to that in Kenya?
Offer a terse response. 1.04. What is the ratio of the Exports (in Local Currency Unit) of 1963 in Italy to that in Kenya?
Offer a terse response. 1.07. What is the difference between the highest and the second highest Exports (in Local Currency Unit) of 1960?
Provide a short and direct response. 4.23e+1. What is the difference between the highest and the second highest Exports (in Local Currency Unit) in 1961?
Offer a terse response. 4.42e+1. What is the difference between the highest and the second highest Exports (in Local Currency Unit) of 1962?
Your answer should be compact. 4.95e+1. What is the difference between the highest and the second highest Exports (in Local Currency Unit) of 1963?
Offer a terse response. 5.50e+1. What is the difference between the highest and the lowest Exports (in Local Currency Unit) of 1960?
Your answer should be very brief. 4.41e+1. What is the difference between the highest and the lowest Exports (in Local Currency Unit) of 1961?
Provide a succinct answer. 4.60e+1. What is the difference between the highest and the lowest Exports (in Local Currency Unit) of 1962?
Provide a succinct answer. 5.15e+1. What is the difference between the highest and the lowest Exports (in Local Currency Unit) of 1963?
Offer a very short reply. 5.72e+1. 